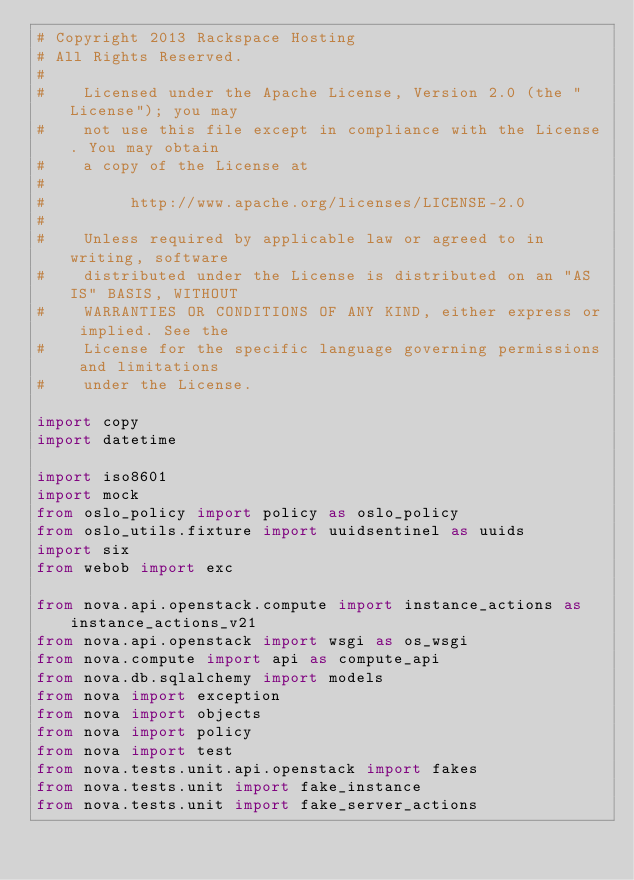<code> <loc_0><loc_0><loc_500><loc_500><_Python_># Copyright 2013 Rackspace Hosting
# All Rights Reserved.
#
#    Licensed under the Apache License, Version 2.0 (the "License"); you may
#    not use this file except in compliance with the License. You may obtain
#    a copy of the License at
#
#         http://www.apache.org/licenses/LICENSE-2.0
#
#    Unless required by applicable law or agreed to in writing, software
#    distributed under the License is distributed on an "AS IS" BASIS, WITHOUT
#    WARRANTIES OR CONDITIONS OF ANY KIND, either express or implied. See the
#    License for the specific language governing permissions and limitations
#    under the License.

import copy
import datetime

import iso8601
import mock
from oslo_policy import policy as oslo_policy
from oslo_utils.fixture import uuidsentinel as uuids
import six
from webob import exc

from nova.api.openstack.compute import instance_actions as instance_actions_v21
from nova.api.openstack import wsgi as os_wsgi
from nova.compute import api as compute_api
from nova.db.sqlalchemy import models
from nova import exception
from nova import objects
from nova import policy
from nova import test
from nova.tests.unit.api.openstack import fakes
from nova.tests.unit import fake_instance
from nova.tests.unit import fake_server_actions</code> 